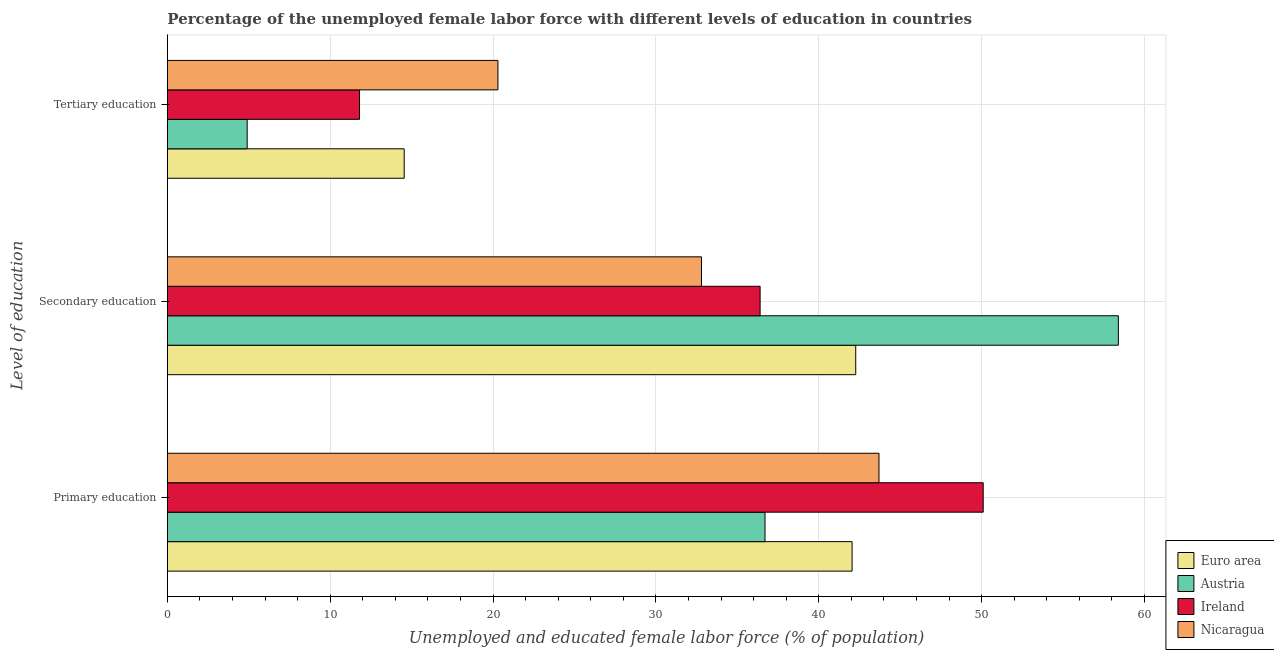How many different coloured bars are there?
Provide a short and direct response. 4. Are the number of bars on each tick of the Y-axis equal?
Offer a terse response. Yes. How many bars are there on the 3rd tick from the top?
Keep it short and to the point. 4. What is the label of the 2nd group of bars from the top?
Ensure brevity in your answer.  Secondary education. What is the percentage of female labor force who received tertiary education in Austria?
Keep it short and to the point. 4.9. Across all countries, what is the maximum percentage of female labor force who received tertiary education?
Provide a succinct answer. 20.3. Across all countries, what is the minimum percentage of female labor force who received tertiary education?
Keep it short and to the point. 4.9. In which country was the percentage of female labor force who received primary education maximum?
Give a very brief answer. Ireland. What is the total percentage of female labor force who received tertiary education in the graph?
Offer a terse response. 51.54. What is the difference between the percentage of female labor force who received primary education in Austria and that in Ireland?
Keep it short and to the point. -13.4. What is the difference between the percentage of female labor force who received primary education in Ireland and the percentage of female labor force who received secondary education in Euro area?
Give a very brief answer. 7.83. What is the average percentage of female labor force who received secondary education per country?
Provide a succinct answer. 42.47. What is the difference between the percentage of female labor force who received primary education and percentage of female labor force who received secondary education in Nicaragua?
Your answer should be very brief. 10.9. In how many countries, is the percentage of female labor force who received secondary education greater than 22 %?
Give a very brief answer. 4. What is the ratio of the percentage of female labor force who received primary education in Nicaragua to that in Austria?
Your answer should be very brief. 1.19. Is the difference between the percentage of female labor force who received tertiary education in Ireland and Euro area greater than the difference between the percentage of female labor force who received primary education in Ireland and Euro area?
Your answer should be compact. No. What is the difference between the highest and the second highest percentage of female labor force who received tertiary education?
Provide a short and direct response. 5.76. What is the difference between the highest and the lowest percentage of female labor force who received secondary education?
Your answer should be very brief. 25.6. What does the 1st bar from the top in Tertiary education represents?
Keep it short and to the point. Nicaragua. What does the 1st bar from the bottom in Secondary education represents?
Your response must be concise. Euro area. Is it the case that in every country, the sum of the percentage of female labor force who received primary education and percentage of female labor force who received secondary education is greater than the percentage of female labor force who received tertiary education?
Offer a very short reply. Yes. Are all the bars in the graph horizontal?
Offer a terse response. Yes. How many countries are there in the graph?
Make the answer very short. 4. Are the values on the major ticks of X-axis written in scientific E-notation?
Make the answer very short. No. Does the graph contain grids?
Provide a succinct answer. Yes. How many legend labels are there?
Offer a very short reply. 4. How are the legend labels stacked?
Your answer should be compact. Vertical. What is the title of the graph?
Give a very brief answer. Percentage of the unemployed female labor force with different levels of education in countries. What is the label or title of the X-axis?
Ensure brevity in your answer.  Unemployed and educated female labor force (% of population). What is the label or title of the Y-axis?
Make the answer very short. Level of education. What is the Unemployed and educated female labor force (% of population) of Euro area in Primary education?
Provide a succinct answer. 42.05. What is the Unemployed and educated female labor force (% of population) in Austria in Primary education?
Provide a short and direct response. 36.7. What is the Unemployed and educated female labor force (% of population) of Ireland in Primary education?
Offer a very short reply. 50.1. What is the Unemployed and educated female labor force (% of population) of Nicaragua in Primary education?
Provide a succinct answer. 43.7. What is the Unemployed and educated female labor force (% of population) of Euro area in Secondary education?
Keep it short and to the point. 42.27. What is the Unemployed and educated female labor force (% of population) in Austria in Secondary education?
Ensure brevity in your answer.  58.4. What is the Unemployed and educated female labor force (% of population) in Ireland in Secondary education?
Offer a very short reply. 36.4. What is the Unemployed and educated female labor force (% of population) in Nicaragua in Secondary education?
Provide a short and direct response. 32.8. What is the Unemployed and educated female labor force (% of population) in Euro area in Tertiary education?
Make the answer very short. 14.54. What is the Unemployed and educated female labor force (% of population) in Austria in Tertiary education?
Keep it short and to the point. 4.9. What is the Unemployed and educated female labor force (% of population) in Ireland in Tertiary education?
Give a very brief answer. 11.8. What is the Unemployed and educated female labor force (% of population) in Nicaragua in Tertiary education?
Your answer should be very brief. 20.3. Across all Level of education, what is the maximum Unemployed and educated female labor force (% of population) of Euro area?
Ensure brevity in your answer.  42.27. Across all Level of education, what is the maximum Unemployed and educated female labor force (% of population) in Austria?
Offer a very short reply. 58.4. Across all Level of education, what is the maximum Unemployed and educated female labor force (% of population) of Ireland?
Offer a very short reply. 50.1. Across all Level of education, what is the maximum Unemployed and educated female labor force (% of population) of Nicaragua?
Your answer should be compact. 43.7. Across all Level of education, what is the minimum Unemployed and educated female labor force (% of population) in Euro area?
Make the answer very short. 14.54. Across all Level of education, what is the minimum Unemployed and educated female labor force (% of population) of Austria?
Provide a short and direct response. 4.9. Across all Level of education, what is the minimum Unemployed and educated female labor force (% of population) of Ireland?
Offer a terse response. 11.8. Across all Level of education, what is the minimum Unemployed and educated female labor force (% of population) of Nicaragua?
Your response must be concise. 20.3. What is the total Unemployed and educated female labor force (% of population) in Euro area in the graph?
Give a very brief answer. 98.86. What is the total Unemployed and educated female labor force (% of population) of Austria in the graph?
Provide a succinct answer. 100. What is the total Unemployed and educated female labor force (% of population) in Ireland in the graph?
Make the answer very short. 98.3. What is the total Unemployed and educated female labor force (% of population) of Nicaragua in the graph?
Offer a terse response. 96.8. What is the difference between the Unemployed and educated female labor force (% of population) of Euro area in Primary education and that in Secondary education?
Your response must be concise. -0.22. What is the difference between the Unemployed and educated female labor force (% of population) in Austria in Primary education and that in Secondary education?
Offer a terse response. -21.7. What is the difference between the Unemployed and educated female labor force (% of population) in Ireland in Primary education and that in Secondary education?
Provide a short and direct response. 13.7. What is the difference between the Unemployed and educated female labor force (% of population) of Euro area in Primary education and that in Tertiary education?
Offer a terse response. 27.51. What is the difference between the Unemployed and educated female labor force (% of population) of Austria in Primary education and that in Tertiary education?
Your answer should be very brief. 31.8. What is the difference between the Unemployed and educated female labor force (% of population) of Ireland in Primary education and that in Tertiary education?
Offer a very short reply. 38.3. What is the difference between the Unemployed and educated female labor force (% of population) in Nicaragua in Primary education and that in Tertiary education?
Ensure brevity in your answer.  23.4. What is the difference between the Unemployed and educated female labor force (% of population) of Euro area in Secondary education and that in Tertiary education?
Keep it short and to the point. 27.73. What is the difference between the Unemployed and educated female labor force (% of population) of Austria in Secondary education and that in Tertiary education?
Your answer should be very brief. 53.5. What is the difference between the Unemployed and educated female labor force (% of population) of Ireland in Secondary education and that in Tertiary education?
Your answer should be compact. 24.6. What is the difference between the Unemployed and educated female labor force (% of population) of Nicaragua in Secondary education and that in Tertiary education?
Keep it short and to the point. 12.5. What is the difference between the Unemployed and educated female labor force (% of population) of Euro area in Primary education and the Unemployed and educated female labor force (% of population) of Austria in Secondary education?
Your answer should be compact. -16.35. What is the difference between the Unemployed and educated female labor force (% of population) in Euro area in Primary education and the Unemployed and educated female labor force (% of population) in Ireland in Secondary education?
Make the answer very short. 5.65. What is the difference between the Unemployed and educated female labor force (% of population) in Euro area in Primary education and the Unemployed and educated female labor force (% of population) in Nicaragua in Secondary education?
Your response must be concise. 9.25. What is the difference between the Unemployed and educated female labor force (% of population) in Austria in Primary education and the Unemployed and educated female labor force (% of population) in Ireland in Secondary education?
Keep it short and to the point. 0.3. What is the difference between the Unemployed and educated female labor force (% of population) in Austria in Primary education and the Unemployed and educated female labor force (% of population) in Nicaragua in Secondary education?
Provide a short and direct response. 3.9. What is the difference between the Unemployed and educated female labor force (% of population) of Ireland in Primary education and the Unemployed and educated female labor force (% of population) of Nicaragua in Secondary education?
Your answer should be very brief. 17.3. What is the difference between the Unemployed and educated female labor force (% of population) of Euro area in Primary education and the Unemployed and educated female labor force (% of population) of Austria in Tertiary education?
Offer a terse response. 37.15. What is the difference between the Unemployed and educated female labor force (% of population) of Euro area in Primary education and the Unemployed and educated female labor force (% of population) of Ireland in Tertiary education?
Your response must be concise. 30.25. What is the difference between the Unemployed and educated female labor force (% of population) in Euro area in Primary education and the Unemployed and educated female labor force (% of population) in Nicaragua in Tertiary education?
Your response must be concise. 21.75. What is the difference between the Unemployed and educated female labor force (% of population) of Austria in Primary education and the Unemployed and educated female labor force (% of population) of Ireland in Tertiary education?
Ensure brevity in your answer.  24.9. What is the difference between the Unemployed and educated female labor force (% of population) in Austria in Primary education and the Unemployed and educated female labor force (% of population) in Nicaragua in Tertiary education?
Your answer should be very brief. 16.4. What is the difference between the Unemployed and educated female labor force (% of population) in Ireland in Primary education and the Unemployed and educated female labor force (% of population) in Nicaragua in Tertiary education?
Give a very brief answer. 29.8. What is the difference between the Unemployed and educated female labor force (% of population) in Euro area in Secondary education and the Unemployed and educated female labor force (% of population) in Austria in Tertiary education?
Offer a terse response. 37.37. What is the difference between the Unemployed and educated female labor force (% of population) in Euro area in Secondary education and the Unemployed and educated female labor force (% of population) in Ireland in Tertiary education?
Provide a succinct answer. 30.47. What is the difference between the Unemployed and educated female labor force (% of population) of Euro area in Secondary education and the Unemployed and educated female labor force (% of population) of Nicaragua in Tertiary education?
Your answer should be compact. 21.97. What is the difference between the Unemployed and educated female labor force (% of population) in Austria in Secondary education and the Unemployed and educated female labor force (% of population) in Ireland in Tertiary education?
Provide a succinct answer. 46.6. What is the difference between the Unemployed and educated female labor force (% of population) of Austria in Secondary education and the Unemployed and educated female labor force (% of population) of Nicaragua in Tertiary education?
Offer a terse response. 38.1. What is the difference between the Unemployed and educated female labor force (% of population) of Ireland in Secondary education and the Unemployed and educated female labor force (% of population) of Nicaragua in Tertiary education?
Make the answer very short. 16.1. What is the average Unemployed and educated female labor force (% of population) of Euro area per Level of education?
Ensure brevity in your answer.  32.95. What is the average Unemployed and educated female labor force (% of population) in Austria per Level of education?
Give a very brief answer. 33.33. What is the average Unemployed and educated female labor force (% of population) of Ireland per Level of education?
Your response must be concise. 32.77. What is the average Unemployed and educated female labor force (% of population) in Nicaragua per Level of education?
Your response must be concise. 32.27. What is the difference between the Unemployed and educated female labor force (% of population) of Euro area and Unemployed and educated female labor force (% of population) of Austria in Primary education?
Give a very brief answer. 5.35. What is the difference between the Unemployed and educated female labor force (% of population) in Euro area and Unemployed and educated female labor force (% of population) in Ireland in Primary education?
Your answer should be compact. -8.05. What is the difference between the Unemployed and educated female labor force (% of population) in Euro area and Unemployed and educated female labor force (% of population) in Nicaragua in Primary education?
Make the answer very short. -1.65. What is the difference between the Unemployed and educated female labor force (% of population) of Austria and Unemployed and educated female labor force (% of population) of Ireland in Primary education?
Keep it short and to the point. -13.4. What is the difference between the Unemployed and educated female labor force (% of population) of Ireland and Unemployed and educated female labor force (% of population) of Nicaragua in Primary education?
Offer a terse response. 6.4. What is the difference between the Unemployed and educated female labor force (% of population) of Euro area and Unemployed and educated female labor force (% of population) of Austria in Secondary education?
Offer a very short reply. -16.13. What is the difference between the Unemployed and educated female labor force (% of population) in Euro area and Unemployed and educated female labor force (% of population) in Ireland in Secondary education?
Give a very brief answer. 5.87. What is the difference between the Unemployed and educated female labor force (% of population) of Euro area and Unemployed and educated female labor force (% of population) of Nicaragua in Secondary education?
Your answer should be compact. 9.47. What is the difference between the Unemployed and educated female labor force (% of population) in Austria and Unemployed and educated female labor force (% of population) in Nicaragua in Secondary education?
Your answer should be very brief. 25.6. What is the difference between the Unemployed and educated female labor force (% of population) of Ireland and Unemployed and educated female labor force (% of population) of Nicaragua in Secondary education?
Give a very brief answer. 3.6. What is the difference between the Unemployed and educated female labor force (% of population) of Euro area and Unemployed and educated female labor force (% of population) of Austria in Tertiary education?
Ensure brevity in your answer.  9.64. What is the difference between the Unemployed and educated female labor force (% of population) in Euro area and Unemployed and educated female labor force (% of population) in Ireland in Tertiary education?
Ensure brevity in your answer.  2.74. What is the difference between the Unemployed and educated female labor force (% of population) of Euro area and Unemployed and educated female labor force (% of population) of Nicaragua in Tertiary education?
Your response must be concise. -5.76. What is the difference between the Unemployed and educated female labor force (% of population) of Austria and Unemployed and educated female labor force (% of population) of Ireland in Tertiary education?
Your response must be concise. -6.9. What is the difference between the Unemployed and educated female labor force (% of population) of Austria and Unemployed and educated female labor force (% of population) of Nicaragua in Tertiary education?
Offer a terse response. -15.4. What is the ratio of the Unemployed and educated female labor force (% of population) of Austria in Primary education to that in Secondary education?
Provide a succinct answer. 0.63. What is the ratio of the Unemployed and educated female labor force (% of population) in Ireland in Primary education to that in Secondary education?
Give a very brief answer. 1.38. What is the ratio of the Unemployed and educated female labor force (% of population) in Nicaragua in Primary education to that in Secondary education?
Ensure brevity in your answer.  1.33. What is the ratio of the Unemployed and educated female labor force (% of population) in Euro area in Primary education to that in Tertiary education?
Offer a terse response. 2.89. What is the ratio of the Unemployed and educated female labor force (% of population) of Austria in Primary education to that in Tertiary education?
Keep it short and to the point. 7.49. What is the ratio of the Unemployed and educated female labor force (% of population) of Ireland in Primary education to that in Tertiary education?
Your response must be concise. 4.25. What is the ratio of the Unemployed and educated female labor force (% of population) of Nicaragua in Primary education to that in Tertiary education?
Provide a succinct answer. 2.15. What is the ratio of the Unemployed and educated female labor force (% of population) of Euro area in Secondary education to that in Tertiary education?
Your answer should be compact. 2.91. What is the ratio of the Unemployed and educated female labor force (% of population) of Austria in Secondary education to that in Tertiary education?
Your response must be concise. 11.92. What is the ratio of the Unemployed and educated female labor force (% of population) in Ireland in Secondary education to that in Tertiary education?
Give a very brief answer. 3.08. What is the ratio of the Unemployed and educated female labor force (% of population) in Nicaragua in Secondary education to that in Tertiary education?
Keep it short and to the point. 1.62. What is the difference between the highest and the second highest Unemployed and educated female labor force (% of population) of Euro area?
Provide a succinct answer. 0.22. What is the difference between the highest and the second highest Unemployed and educated female labor force (% of population) of Austria?
Offer a very short reply. 21.7. What is the difference between the highest and the second highest Unemployed and educated female labor force (% of population) of Nicaragua?
Keep it short and to the point. 10.9. What is the difference between the highest and the lowest Unemployed and educated female labor force (% of population) in Euro area?
Offer a very short reply. 27.73. What is the difference between the highest and the lowest Unemployed and educated female labor force (% of population) in Austria?
Provide a succinct answer. 53.5. What is the difference between the highest and the lowest Unemployed and educated female labor force (% of population) in Ireland?
Your answer should be very brief. 38.3. What is the difference between the highest and the lowest Unemployed and educated female labor force (% of population) of Nicaragua?
Give a very brief answer. 23.4. 